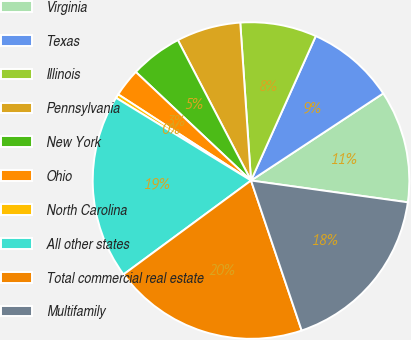Convert chart to OTSL. <chart><loc_0><loc_0><loc_500><loc_500><pie_chart><fcel>Virginia<fcel>Texas<fcel>Illinois<fcel>Pennsylvania<fcel>New York<fcel>Ohio<fcel>North Carolina<fcel>All other states<fcel>Total commercial real estate<fcel>Multifamily<nl><fcel>11.47%<fcel>9.02%<fcel>7.79%<fcel>6.56%<fcel>5.33%<fcel>2.87%<fcel>0.41%<fcel>18.85%<fcel>20.08%<fcel>17.62%<nl></chart> 